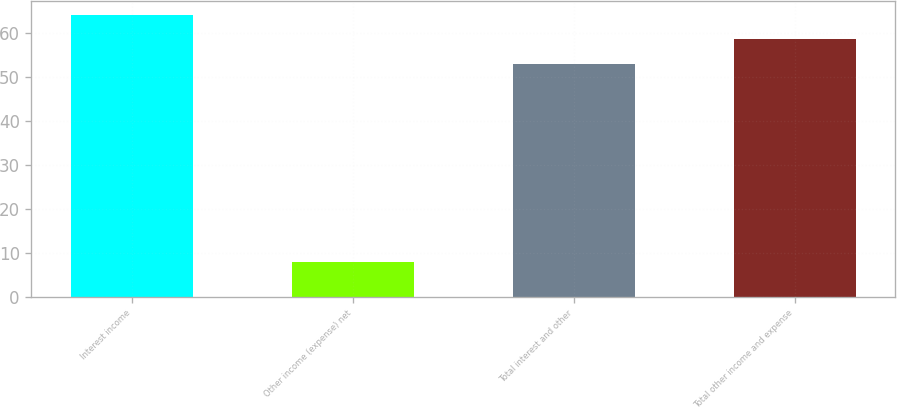<chart> <loc_0><loc_0><loc_500><loc_500><bar_chart><fcel>Interest income<fcel>Other income (expense) net<fcel>Total interest and other<fcel>Total other income and expense<nl><fcel>64.2<fcel>8<fcel>53<fcel>58.6<nl></chart> 